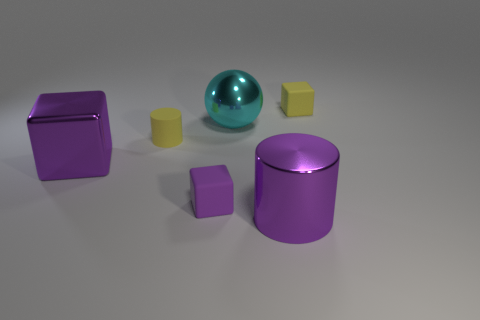Add 1 small cylinders. How many objects exist? 7 Subtract all tiny matte cubes. How many cubes are left? 1 Subtract all purple cubes. How many cubes are left? 1 Subtract all gray blocks. How many purple cylinders are left? 1 Subtract all small rubber blocks. Subtract all small yellow matte objects. How many objects are left? 2 Add 3 purple cylinders. How many purple cylinders are left? 4 Add 3 gray metal blocks. How many gray metal blocks exist? 3 Subtract 0 cyan blocks. How many objects are left? 6 Subtract all spheres. How many objects are left? 5 Subtract 1 cylinders. How many cylinders are left? 1 